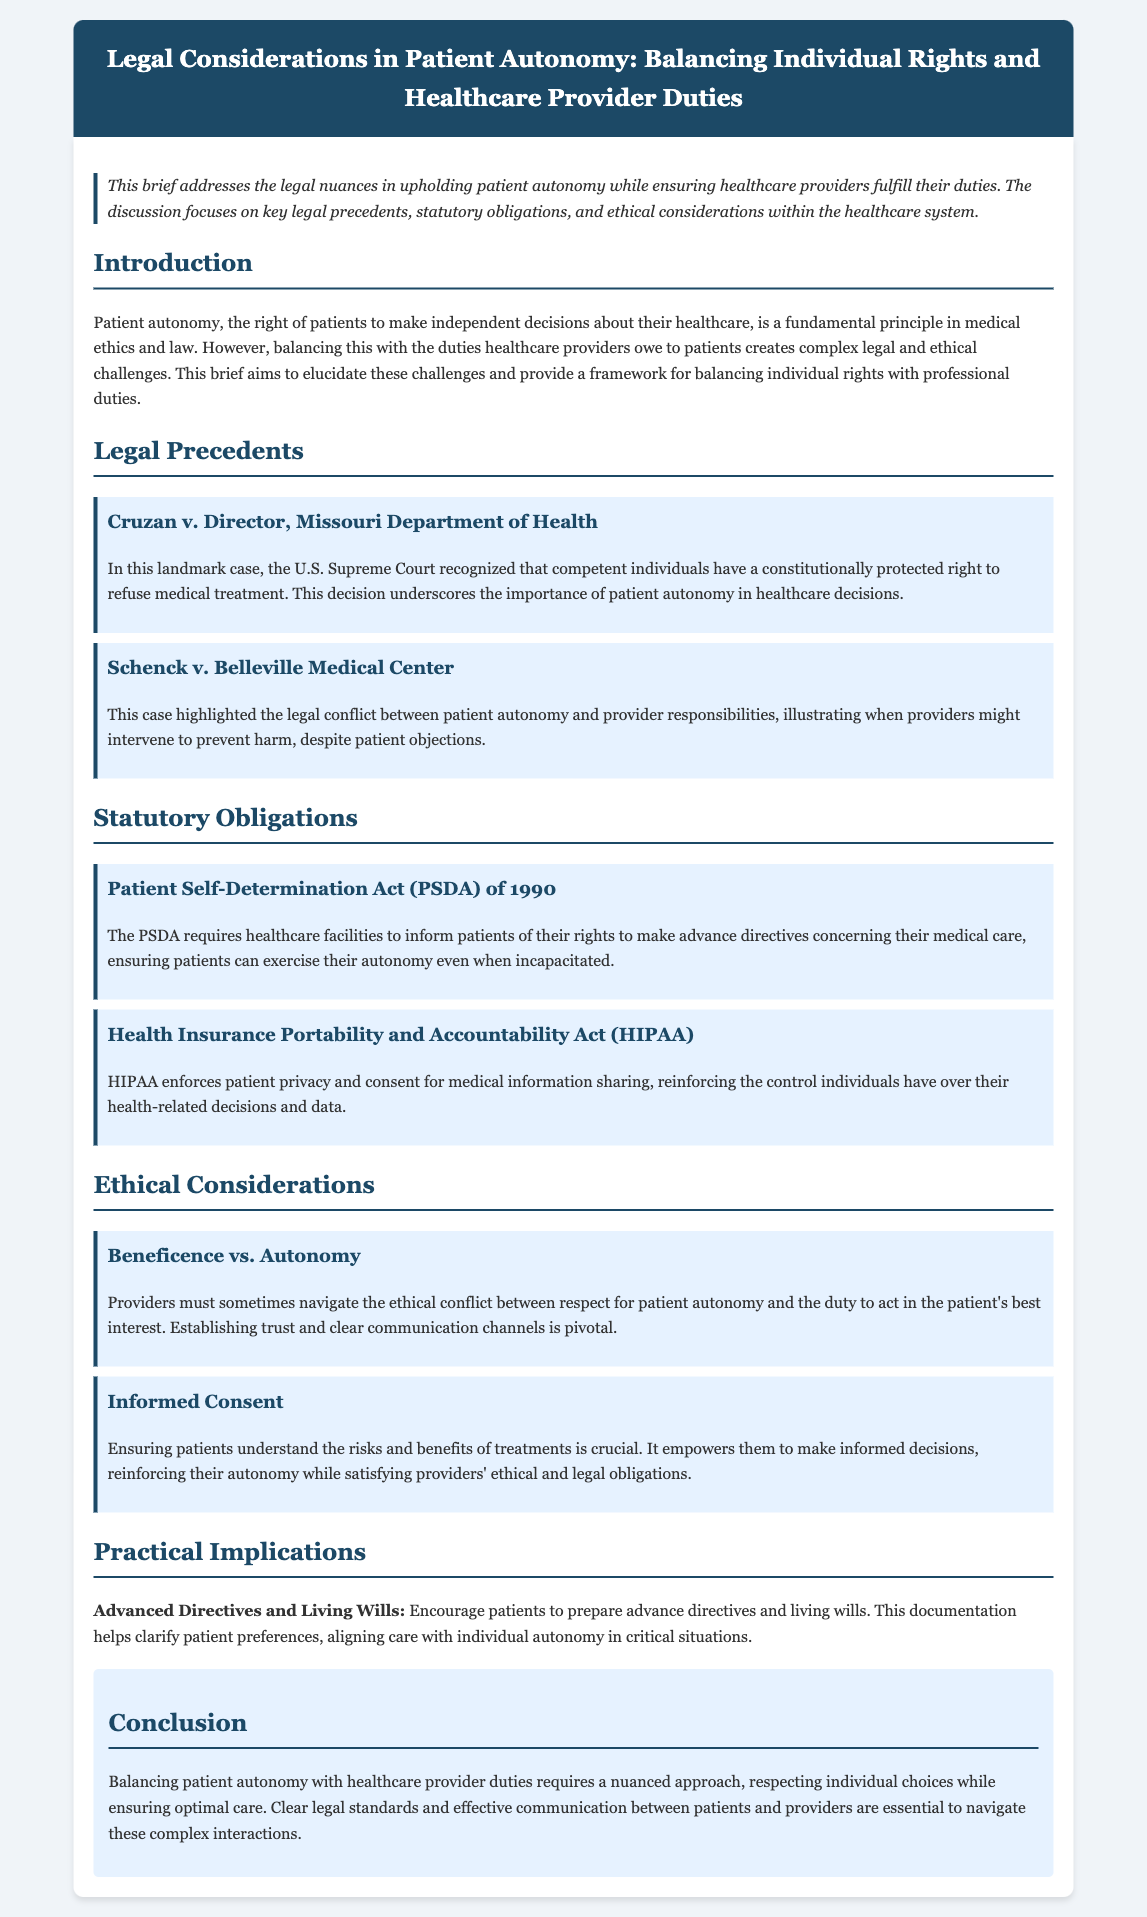What is the title of the legal brief? The title is provided at the header of the document.
Answer: Legal Considerations in Patient Autonomy: Balancing Individual Rights and Healthcare Provider Duties What landmark case recognized the right to refuse medical treatment? The case is mentioned under the legal precedents section.
Answer: Cruzan v. Director, Missouri Department of Health What year was the Patient Self-Determination Act enacted? This information can be found in the statutory obligations section.
Answer: 1990 What ethical principle must providers navigate alongside patient autonomy? This principle is referenced in the ethical considerations section.
Answer: Beneficence What does HIPAA enforce regarding patient information? The enforcement aspect is described in the statutory obligations section.
Answer: Patient privacy and consent What document encourages patients to clarify their preferences? The document is discussed in the practical implications section.
Answer: Advance directives and living wills How is informed consent described in the brief? The description is found under ethical considerations.
Answer: It empowers them to make informed decisions What is crucial for balancing individual rights and provider duties? This necessity is stated in the conclusion of the document.
Answer: Clear legal standards and effective communication 